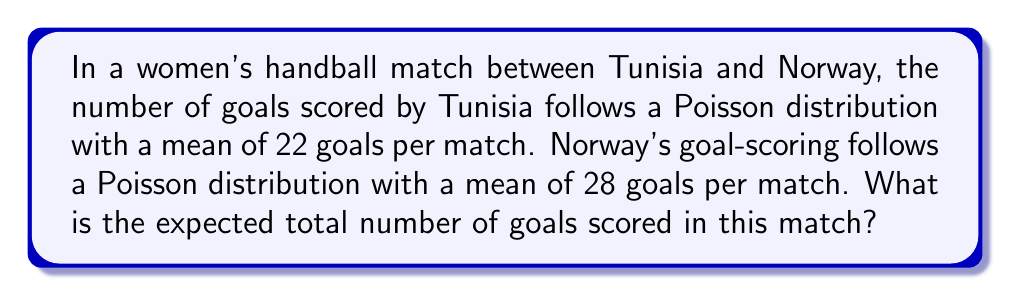Can you answer this question? Let's approach this step-by-step:

1) Let $X$ be the random variable representing the number of goals scored by Tunisia, and $Y$ be the random variable representing the number of goals scored by Norway.

2) We're given that:
   $X \sim \text{Poisson}(\lambda_1 = 22)$
   $Y \sim \text{Poisson}(\lambda_2 = 28)$

3) We need to find $E[X + Y]$, which is the expected total number of goals.

4) A key property of expected values is linearity:
   $E[X + Y] = E[X] + E[Y]$

5) For a Poisson distribution, the expected value is equal to its parameter $\lambda$. So:
   $E[X] = \lambda_1 = 22$
   $E[Y] = \lambda_2 = 28$

6) Therefore:
   $E[X + Y] = E[X] + E[Y] = 22 + 28 = 50$

Thus, the expected total number of goals in the match is 50.
Answer: 50 goals 